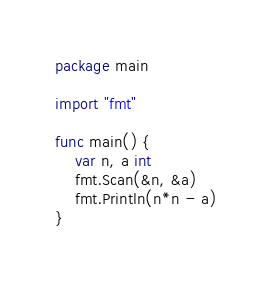<code> <loc_0><loc_0><loc_500><loc_500><_Go_>package main

import "fmt"

func main() {
	var n, a int
	fmt.Scan(&n, &a)
	fmt.Println(n*n - a)
}
</code> 